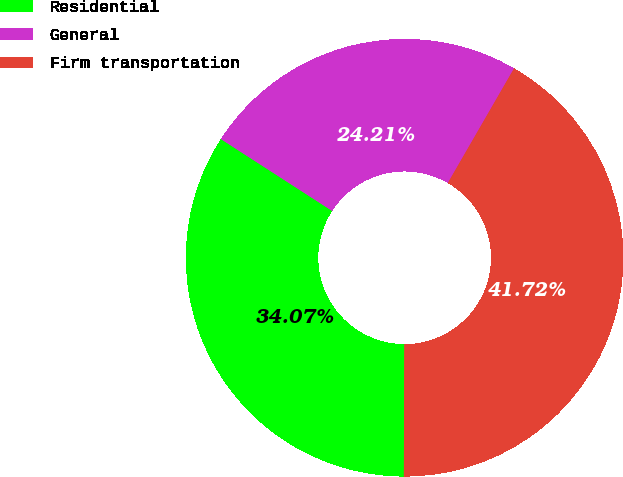Convert chart. <chart><loc_0><loc_0><loc_500><loc_500><pie_chart><fcel>Residential<fcel>General<fcel>Firm transportation<nl><fcel>34.07%<fcel>24.21%<fcel>41.72%<nl></chart> 